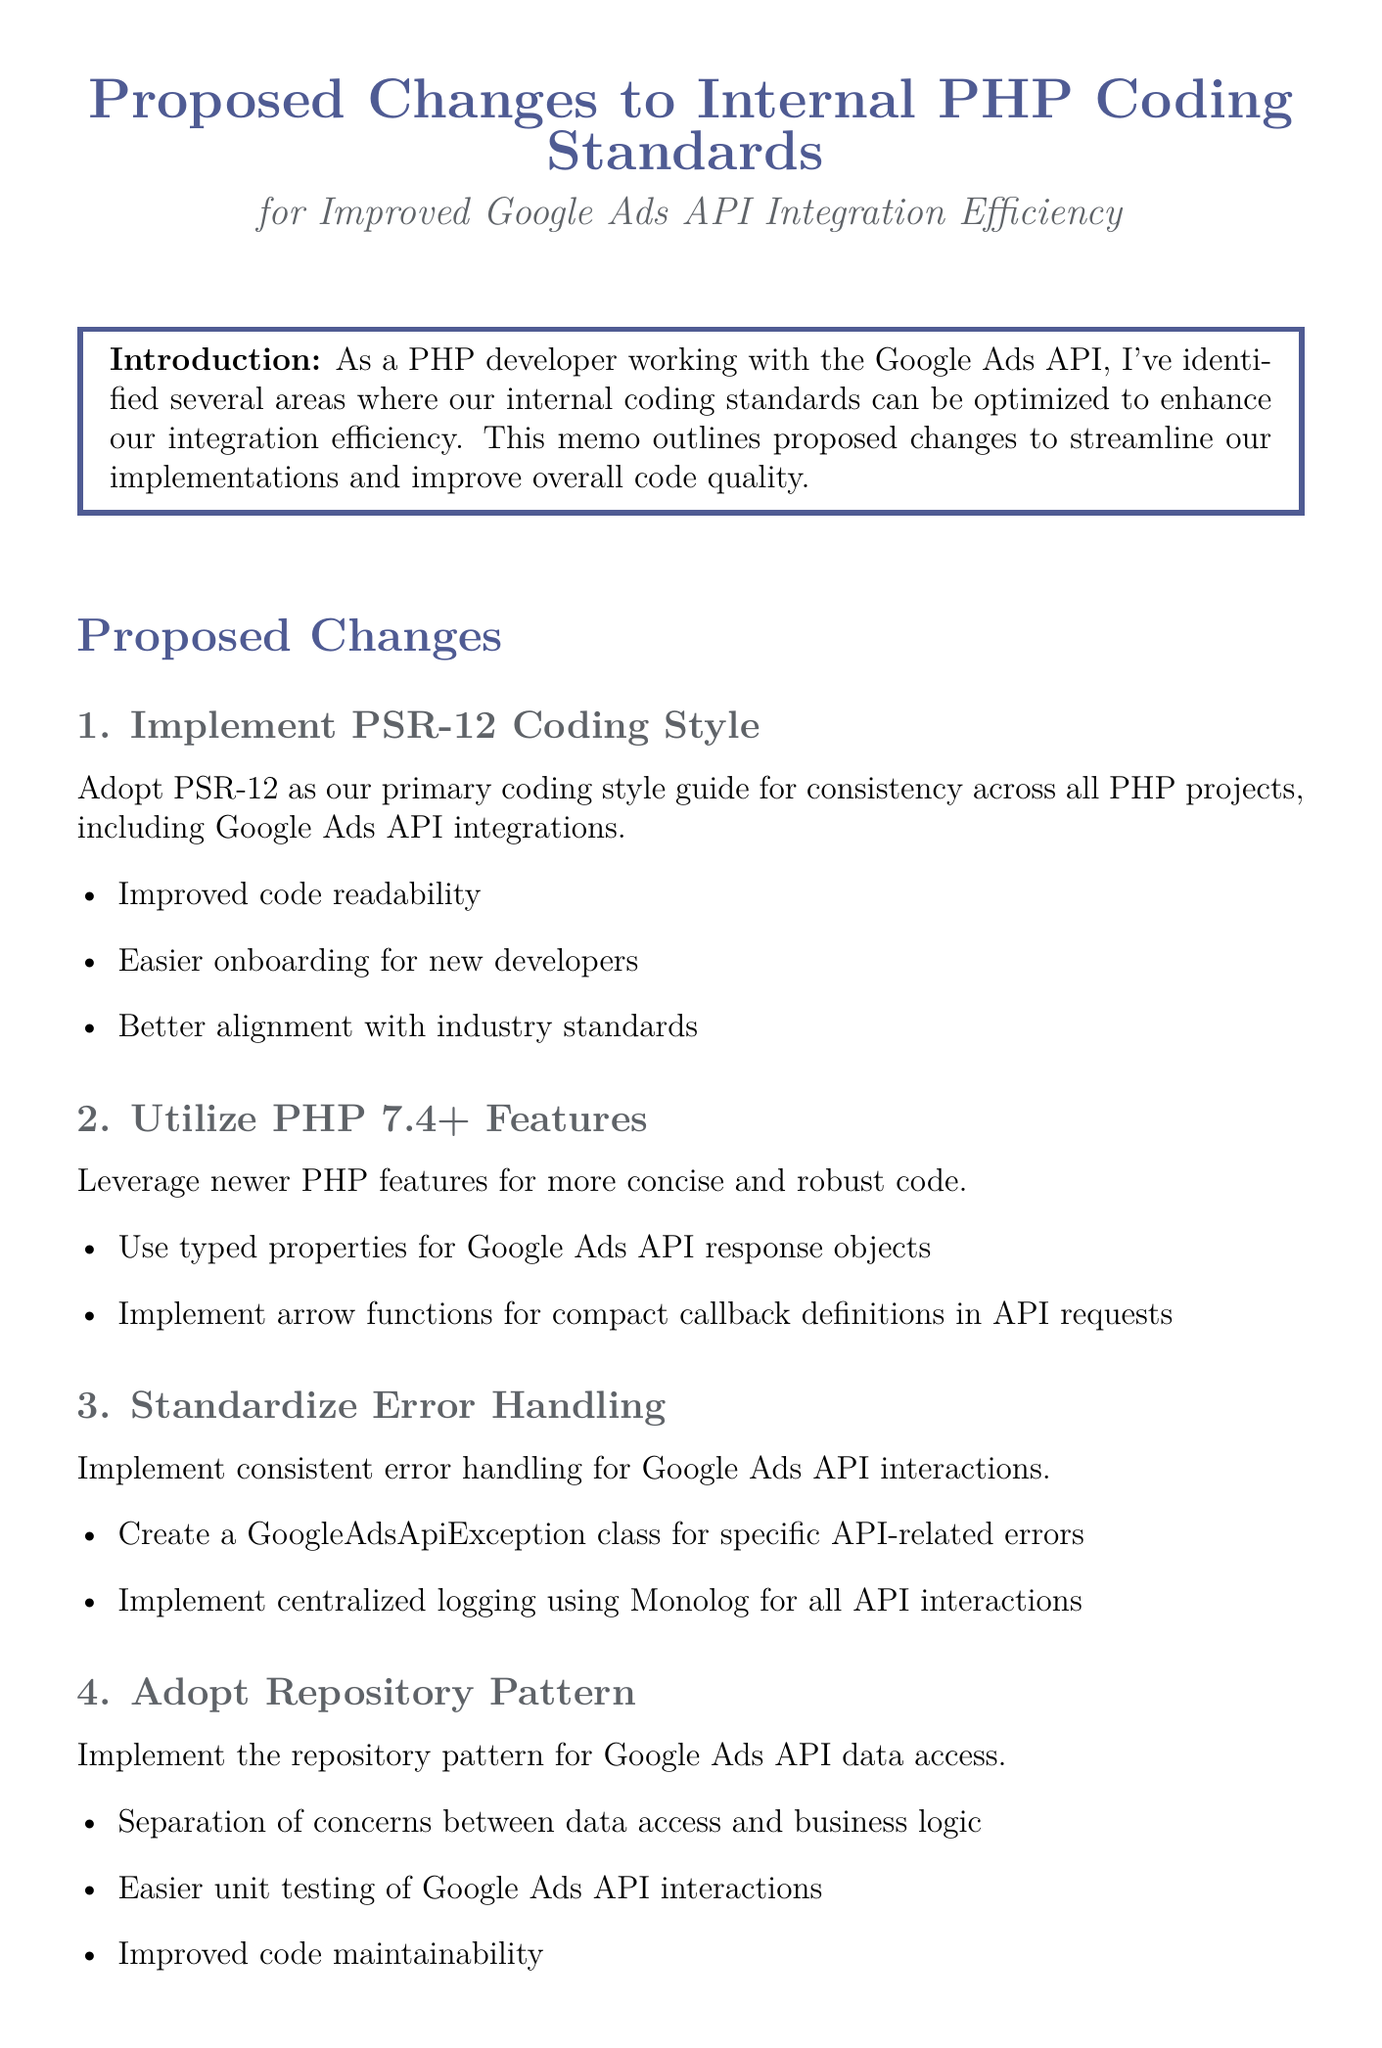What is the memo title? The memo title is explicitly stated at the beginning of the document.
Answer: Proposed Changes to Internal PHP Coding Standards for Improved Google Ads API Integration Efficiency What is the primary coding style guide proposed? The document outlines proposed changes, including the adoption of a specific coding style guide.
Answer: PSR-12 What are two newer PHP features mentioned for utilization? The section discusses leveraging newer PHP features, detailing specific examples.
Answer: typed properties, arrow functions What is the name of the class proposed for specific API-related errors? The document discusses implementing a custom exception class for error handling.
Answer: GoogleAdsApiException What is the proposed implementation timeline? The timeline for implementation is clearly stated in the document.
Answer: 3 months Which dependency injection container is suggested to be adopted? The proposed changes specifically mention a dependency injection container to be used.
Answer: PHP-DI What is one benefit of adopting the repository pattern? The benefits of the repository pattern are listed in relation to data access and logic separation.
Answer: Separation of concerns What is the first phase of the implementation plan? The implementation plan details various phases, starting with a specific focus.
Answer: Documentation and Training What type of error handling system is proposed to be centralized? The document mentions the use of a specific logging system for error handling.
Answer: Monolog 